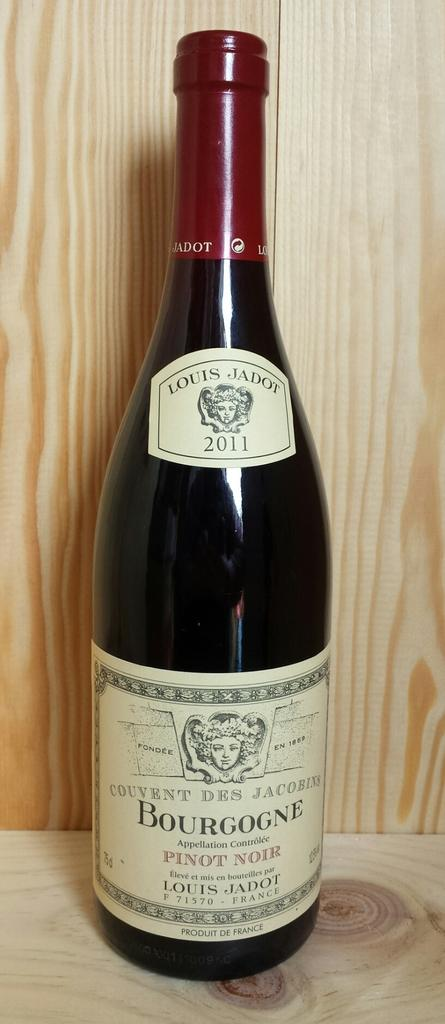<image>
Summarize the visual content of the image. 2011 bottle of bourgogne pinot noir on a wood shelf 